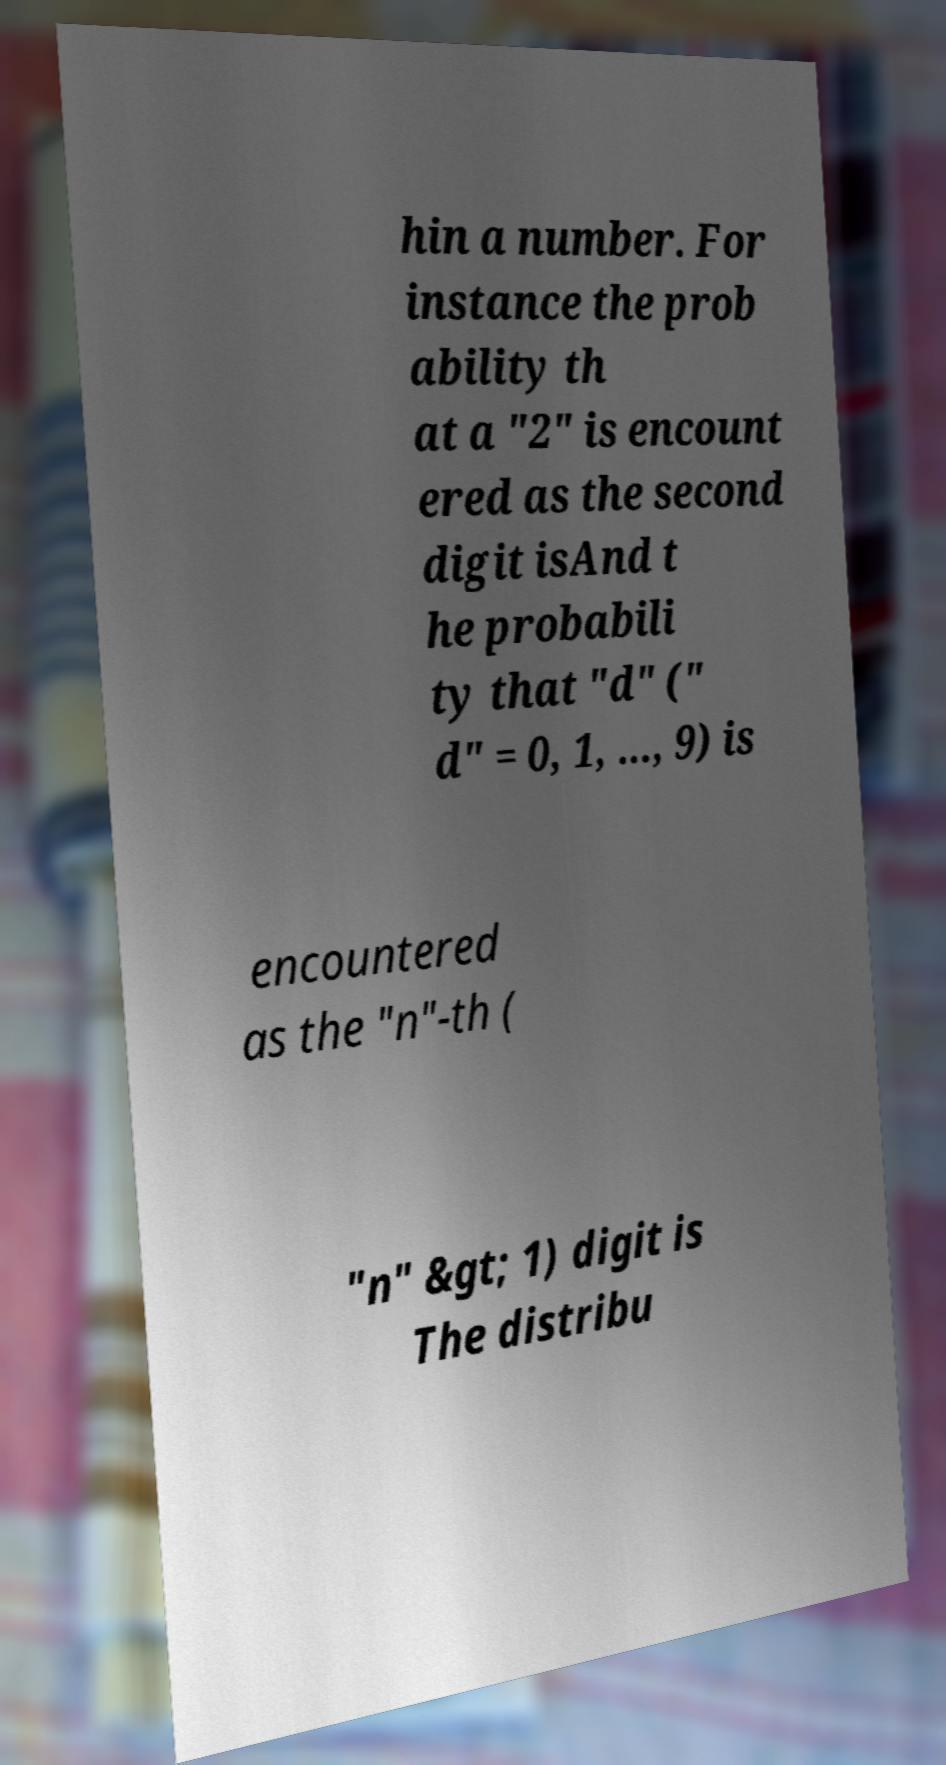What messages or text are displayed in this image? I need them in a readable, typed format. hin a number. For instance the prob ability th at a "2" is encount ered as the second digit isAnd t he probabili ty that "d" (" d" = 0, 1, ..., 9) is encountered as the "n"-th ( "n" &gt; 1) digit is The distribu 